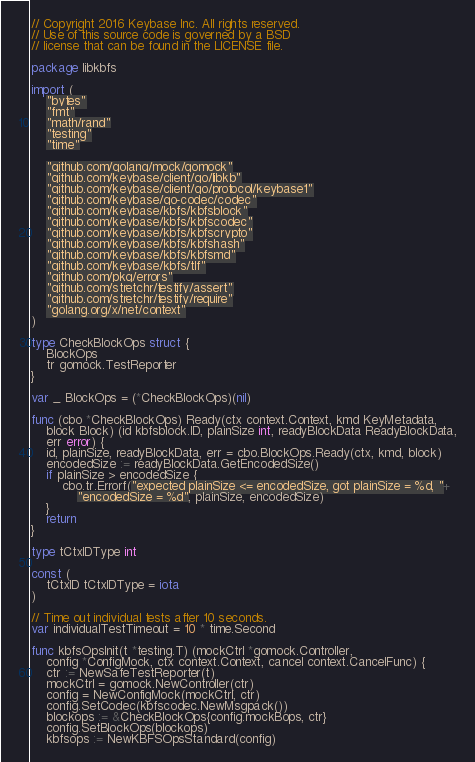Convert code to text. <code><loc_0><loc_0><loc_500><loc_500><_Go_>// Copyright 2016 Keybase Inc. All rights reserved.
// Use of this source code is governed by a BSD
// license that can be found in the LICENSE file.

package libkbfs

import (
	"bytes"
	"fmt"
	"math/rand"
	"testing"
	"time"

	"github.com/golang/mock/gomock"
	"github.com/keybase/client/go/libkb"
	"github.com/keybase/client/go/protocol/keybase1"
	"github.com/keybase/go-codec/codec"
	"github.com/keybase/kbfs/kbfsblock"
	"github.com/keybase/kbfs/kbfscodec"
	"github.com/keybase/kbfs/kbfscrypto"
	"github.com/keybase/kbfs/kbfshash"
	"github.com/keybase/kbfs/kbfsmd"
	"github.com/keybase/kbfs/tlf"
	"github.com/pkg/errors"
	"github.com/stretchr/testify/assert"
	"github.com/stretchr/testify/require"
	"golang.org/x/net/context"
)

type CheckBlockOps struct {
	BlockOps
	tr gomock.TestReporter
}

var _ BlockOps = (*CheckBlockOps)(nil)

func (cbo *CheckBlockOps) Ready(ctx context.Context, kmd KeyMetadata,
	block Block) (id kbfsblock.ID, plainSize int, readyBlockData ReadyBlockData,
	err error) {
	id, plainSize, readyBlockData, err = cbo.BlockOps.Ready(ctx, kmd, block)
	encodedSize := readyBlockData.GetEncodedSize()
	if plainSize > encodedSize {
		cbo.tr.Errorf("expected plainSize <= encodedSize, got plainSize = %d, "+
			"encodedSize = %d", plainSize, encodedSize)
	}
	return
}

type tCtxIDType int

const (
	tCtxID tCtxIDType = iota
)

// Time out individual tests after 10 seconds.
var individualTestTimeout = 10 * time.Second

func kbfsOpsInit(t *testing.T) (mockCtrl *gomock.Controller,
	config *ConfigMock, ctx context.Context, cancel context.CancelFunc) {
	ctr := NewSafeTestReporter(t)
	mockCtrl = gomock.NewController(ctr)
	config = NewConfigMock(mockCtrl, ctr)
	config.SetCodec(kbfscodec.NewMsgpack())
	blockops := &CheckBlockOps{config.mockBops, ctr}
	config.SetBlockOps(blockops)
	kbfsops := NewKBFSOpsStandard(config)</code> 